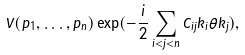<formula> <loc_0><loc_0><loc_500><loc_500>V ( p _ { 1 } , \dots , p _ { n } ) \exp ( - \frac { i } { 2 } \sum _ { i < j < n } C _ { i j } k _ { i } \theta k _ { j } ) ,</formula> 